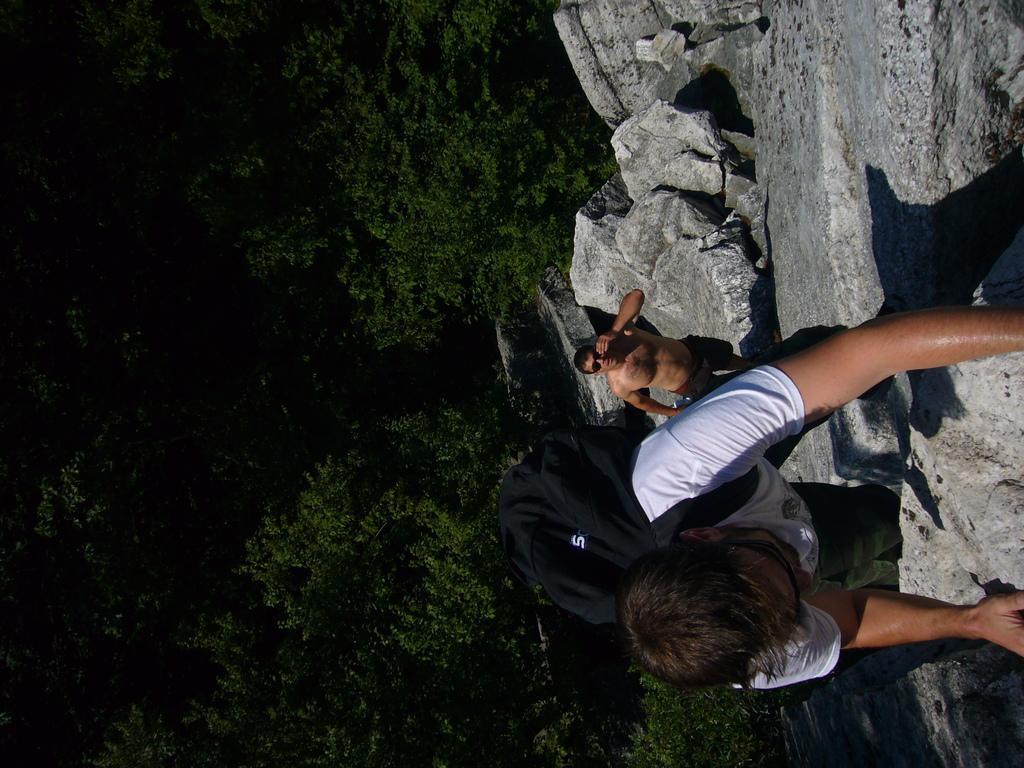Describe this image in one or two sentences. In this image I can see two people. One person is climbing and wearing black bag. I can see trees. 